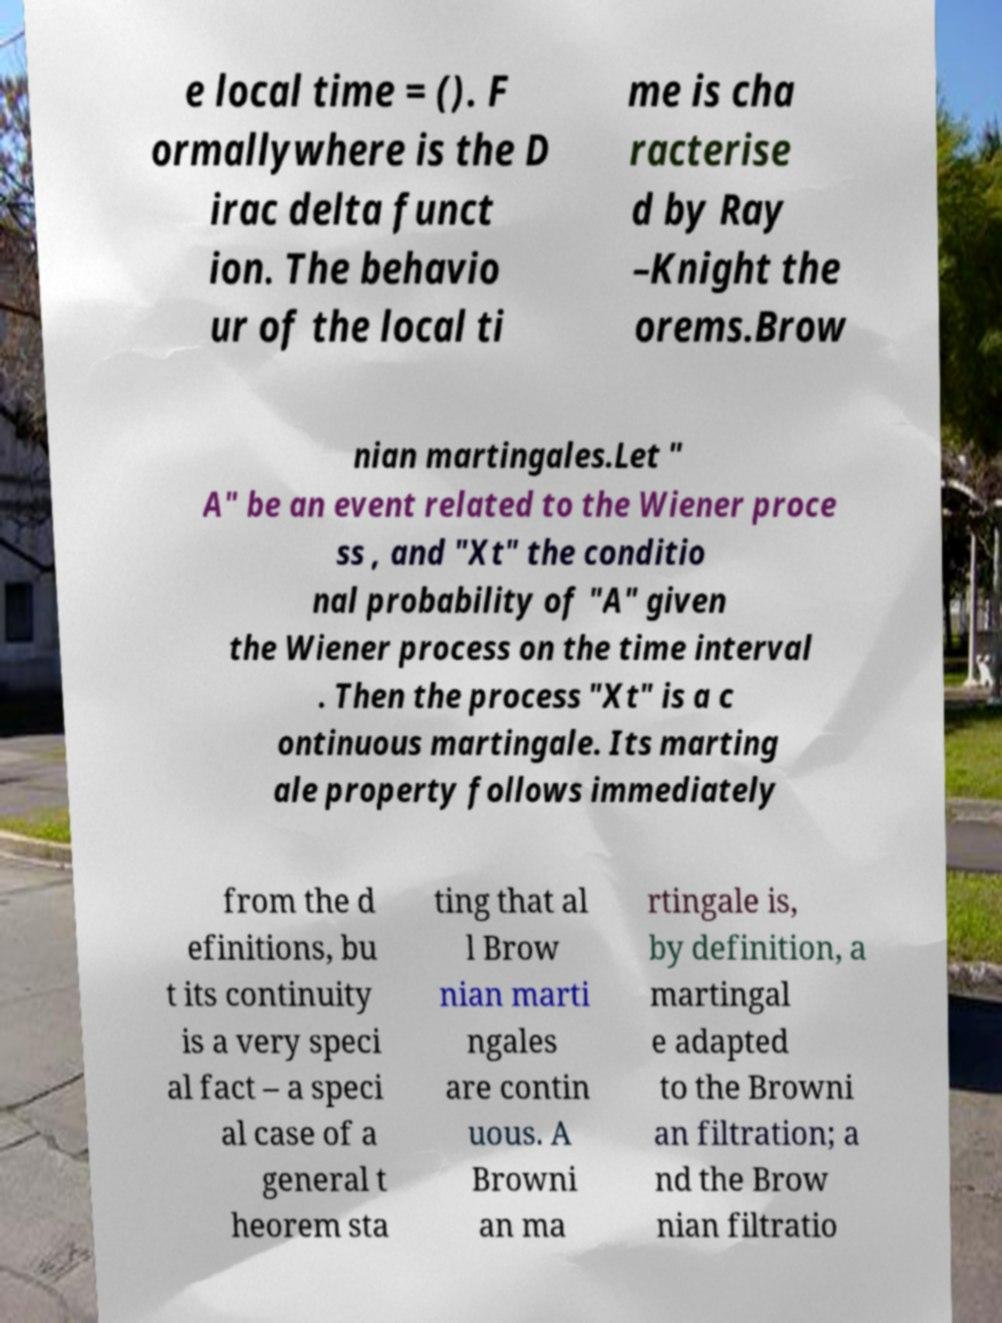Could you extract and type out the text from this image? e local time = (). F ormallywhere is the D irac delta funct ion. The behavio ur of the local ti me is cha racterise d by Ray –Knight the orems.Brow nian martingales.Let " A" be an event related to the Wiener proce ss , and "Xt" the conditio nal probability of "A" given the Wiener process on the time interval . Then the process "Xt" is a c ontinuous martingale. Its marting ale property follows immediately from the d efinitions, bu t its continuity is a very speci al fact – a speci al case of a general t heorem sta ting that al l Brow nian marti ngales are contin uous. A Browni an ma rtingale is, by definition, a martingal e adapted to the Browni an filtration; a nd the Brow nian filtratio 